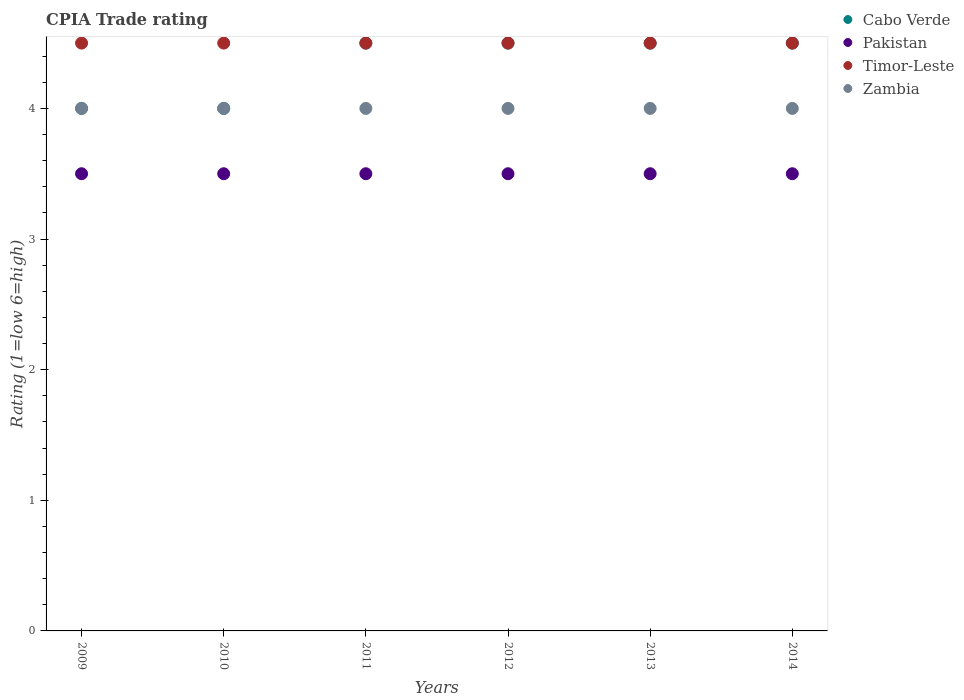Across all years, what is the minimum CPIA rating in Timor-Leste?
Your answer should be compact. 4.5. What is the difference between the CPIA rating in Pakistan in 2010 and that in 2012?
Ensure brevity in your answer.  0. What is the ratio of the CPIA rating in Pakistan in 2010 to that in 2014?
Give a very brief answer. 1. Is the difference between the CPIA rating in Cabo Verde in 2009 and 2013 greater than the difference between the CPIA rating in Pakistan in 2009 and 2013?
Your answer should be very brief. No. In how many years, is the CPIA rating in Timor-Leste greater than the average CPIA rating in Timor-Leste taken over all years?
Make the answer very short. 0. Is it the case that in every year, the sum of the CPIA rating in Cabo Verde and CPIA rating in Zambia  is greater than the sum of CPIA rating in Timor-Leste and CPIA rating in Pakistan?
Your answer should be very brief. Yes. Is the CPIA rating in Timor-Leste strictly less than the CPIA rating in Cabo Verde over the years?
Your answer should be very brief. No. Does the graph contain grids?
Keep it short and to the point. No. Where does the legend appear in the graph?
Make the answer very short. Top right. How many legend labels are there?
Your answer should be compact. 4. How are the legend labels stacked?
Your response must be concise. Vertical. What is the title of the graph?
Your response must be concise. CPIA Trade rating. Does "Russian Federation" appear as one of the legend labels in the graph?
Give a very brief answer. No. What is the label or title of the X-axis?
Keep it short and to the point. Years. What is the label or title of the Y-axis?
Provide a succinct answer. Rating (1=low 6=high). What is the Rating (1=low 6=high) in Timor-Leste in 2009?
Your response must be concise. 4.5. What is the Rating (1=low 6=high) in Zambia in 2009?
Provide a succinct answer. 4. What is the Rating (1=low 6=high) in Pakistan in 2010?
Provide a short and direct response. 3.5. What is the Rating (1=low 6=high) of Zambia in 2011?
Provide a succinct answer. 4. What is the Rating (1=low 6=high) of Cabo Verde in 2012?
Make the answer very short. 4.5. What is the Rating (1=low 6=high) in Pakistan in 2012?
Your answer should be compact. 3.5. What is the Rating (1=low 6=high) of Timor-Leste in 2012?
Offer a terse response. 4.5. What is the Rating (1=low 6=high) in Zambia in 2012?
Offer a very short reply. 4. What is the Rating (1=low 6=high) of Pakistan in 2013?
Keep it short and to the point. 3.5. What is the Rating (1=low 6=high) in Cabo Verde in 2014?
Your answer should be very brief. 4.5. Across all years, what is the maximum Rating (1=low 6=high) of Pakistan?
Make the answer very short. 3.5. Across all years, what is the maximum Rating (1=low 6=high) of Timor-Leste?
Keep it short and to the point. 4.5. Across all years, what is the maximum Rating (1=low 6=high) of Zambia?
Keep it short and to the point. 4. Across all years, what is the minimum Rating (1=low 6=high) of Pakistan?
Your answer should be very brief. 3.5. Across all years, what is the minimum Rating (1=low 6=high) of Timor-Leste?
Offer a very short reply. 4.5. What is the total Rating (1=low 6=high) of Pakistan in the graph?
Ensure brevity in your answer.  21. What is the total Rating (1=low 6=high) of Timor-Leste in the graph?
Provide a short and direct response. 27. What is the difference between the Rating (1=low 6=high) of Timor-Leste in 2009 and that in 2011?
Make the answer very short. 0. What is the difference between the Rating (1=low 6=high) in Cabo Verde in 2009 and that in 2012?
Provide a succinct answer. -0.5. What is the difference between the Rating (1=low 6=high) of Pakistan in 2009 and that in 2012?
Give a very brief answer. 0. What is the difference between the Rating (1=low 6=high) in Zambia in 2009 and that in 2012?
Provide a short and direct response. 0. What is the difference between the Rating (1=low 6=high) in Pakistan in 2009 and that in 2013?
Keep it short and to the point. 0. What is the difference between the Rating (1=low 6=high) in Timor-Leste in 2009 and that in 2013?
Make the answer very short. 0. What is the difference between the Rating (1=low 6=high) in Zambia in 2009 and that in 2013?
Ensure brevity in your answer.  0. What is the difference between the Rating (1=low 6=high) of Zambia in 2009 and that in 2014?
Your response must be concise. 0. What is the difference between the Rating (1=low 6=high) of Pakistan in 2010 and that in 2011?
Provide a short and direct response. 0. What is the difference between the Rating (1=low 6=high) in Pakistan in 2010 and that in 2012?
Provide a short and direct response. 0. What is the difference between the Rating (1=low 6=high) in Zambia in 2010 and that in 2012?
Provide a short and direct response. 0. What is the difference between the Rating (1=low 6=high) in Cabo Verde in 2010 and that in 2013?
Your answer should be very brief. -0.5. What is the difference between the Rating (1=low 6=high) in Pakistan in 2010 and that in 2013?
Your response must be concise. 0. What is the difference between the Rating (1=low 6=high) in Cabo Verde in 2010 and that in 2014?
Your response must be concise. -0.5. What is the difference between the Rating (1=low 6=high) in Pakistan in 2010 and that in 2014?
Your answer should be very brief. 0. What is the difference between the Rating (1=low 6=high) in Timor-Leste in 2010 and that in 2014?
Make the answer very short. 0. What is the difference between the Rating (1=low 6=high) in Cabo Verde in 2011 and that in 2012?
Provide a succinct answer. 0. What is the difference between the Rating (1=low 6=high) in Zambia in 2011 and that in 2012?
Offer a terse response. 0. What is the difference between the Rating (1=low 6=high) of Cabo Verde in 2011 and that in 2013?
Keep it short and to the point. 0. What is the difference between the Rating (1=low 6=high) in Cabo Verde in 2011 and that in 2014?
Offer a very short reply. 0. What is the difference between the Rating (1=low 6=high) in Pakistan in 2011 and that in 2014?
Keep it short and to the point. 0. What is the difference between the Rating (1=low 6=high) of Timor-Leste in 2011 and that in 2014?
Keep it short and to the point. 0. What is the difference between the Rating (1=low 6=high) of Zambia in 2011 and that in 2014?
Provide a short and direct response. 0. What is the difference between the Rating (1=low 6=high) in Cabo Verde in 2012 and that in 2013?
Your response must be concise. 0. What is the difference between the Rating (1=low 6=high) of Pakistan in 2012 and that in 2013?
Provide a succinct answer. 0. What is the difference between the Rating (1=low 6=high) in Timor-Leste in 2012 and that in 2013?
Keep it short and to the point. 0. What is the difference between the Rating (1=low 6=high) in Zambia in 2012 and that in 2013?
Your answer should be compact. 0. What is the difference between the Rating (1=low 6=high) in Cabo Verde in 2012 and that in 2014?
Provide a succinct answer. 0. What is the difference between the Rating (1=low 6=high) of Pakistan in 2012 and that in 2014?
Your answer should be compact. 0. What is the difference between the Rating (1=low 6=high) in Timor-Leste in 2012 and that in 2014?
Give a very brief answer. 0. What is the difference between the Rating (1=low 6=high) in Zambia in 2013 and that in 2014?
Provide a succinct answer. 0. What is the difference between the Rating (1=low 6=high) of Cabo Verde in 2009 and the Rating (1=low 6=high) of Pakistan in 2010?
Your answer should be very brief. 0.5. What is the difference between the Rating (1=low 6=high) of Cabo Verde in 2009 and the Rating (1=low 6=high) of Zambia in 2010?
Your answer should be very brief. 0. What is the difference between the Rating (1=low 6=high) in Pakistan in 2009 and the Rating (1=low 6=high) in Timor-Leste in 2010?
Offer a very short reply. -1. What is the difference between the Rating (1=low 6=high) of Pakistan in 2009 and the Rating (1=low 6=high) of Zambia in 2010?
Provide a succinct answer. -0.5. What is the difference between the Rating (1=low 6=high) of Timor-Leste in 2009 and the Rating (1=low 6=high) of Zambia in 2010?
Your response must be concise. 0.5. What is the difference between the Rating (1=low 6=high) in Cabo Verde in 2009 and the Rating (1=low 6=high) in Timor-Leste in 2011?
Give a very brief answer. -0.5. What is the difference between the Rating (1=low 6=high) in Cabo Verde in 2009 and the Rating (1=low 6=high) in Zambia in 2011?
Your answer should be compact. 0. What is the difference between the Rating (1=low 6=high) in Pakistan in 2009 and the Rating (1=low 6=high) in Zambia in 2011?
Ensure brevity in your answer.  -0.5. What is the difference between the Rating (1=low 6=high) in Timor-Leste in 2009 and the Rating (1=low 6=high) in Zambia in 2011?
Your response must be concise. 0.5. What is the difference between the Rating (1=low 6=high) in Cabo Verde in 2009 and the Rating (1=low 6=high) in Pakistan in 2012?
Your answer should be very brief. 0.5. What is the difference between the Rating (1=low 6=high) in Cabo Verde in 2009 and the Rating (1=low 6=high) in Timor-Leste in 2012?
Ensure brevity in your answer.  -0.5. What is the difference between the Rating (1=low 6=high) in Cabo Verde in 2009 and the Rating (1=low 6=high) in Zambia in 2012?
Give a very brief answer. 0. What is the difference between the Rating (1=low 6=high) in Timor-Leste in 2009 and the Rating (1=low 6=high) in Zambia in 2012?
Keep it short and to the point. 0.5. What is the difference between the Rating (1=low 6=high) of Cabo Verde in 2009 and the Rating (1=low 6=high) of Timor-Leste in 2013?
Your answer should be compact. -0.5. What is the difference between the Rating (1=low 6=high) of Pakistan in 2009 and the Rating (1=low 6=high) of Zambia in 2013?
Ensure brevity in your answer.  -0.5. What is the difference between the Rating (1=low 6=high) of Timor-Leste in 2009 and the Rating (1=low 6=high) of Zambia in 2013?
Offer a very short reply. 0.5. What is the difference between the Rating (1=low 6=high) in Pakistan in 2009 and the Rating (1=low 6=high) in Timor-Leste in 2014?
Provide a short and direct response. -1. What is the difference between the Rating (1=low 6=high) in Cabo Verde in 2010 and the Rating (1=low 6=high) in Pakistan in 2011?
Your response must be concise. 0.5. What is the difference between the Rating (1=low 6=high) in Cabo Verde in 2010 and the Rating (1=low 6=high) in Timor-Leste in 2011?
Make the answer very short. -0.5. What is the difference between the Rating (1=low 6=high) of Cabo Verde in 2010 and the Rating (1=low 6=high) of Zambia in 2011?
Keep it short and to the point. 0. What is the difference between the Rating (1=low 6=high) of Pakistan in 2010 and the Rating (1=low 6=high) of Zambia in 2011?
Provide a short and direct response. -0.5. What is the difference between the Rating (1=low 6=high) in Cabo Verde in 2010 and the Rating (1=low 6=high) in Zambia in 2012?
Your response must be concise. 0. What is the difference between the Rating (1=low 6=high) in Pakistan in 2010 and the Rating (1=low 6=high) in Timor-Leste in 2012?
Your answer should be compact. -1. What is the difference between the Rating (1=low 6=high) of Pakistan in 2010 and the Rating (1=low 6=high) of Zambia in 2012?
Your answer should be very brief. -0.5. What is the difference between the Rating (1=low 6=high) in Cabo Verde in 2010 and the Rating (1=low 6=high) in Pakistan in 2013?
Your answer should be compact. 0.5. What is the difference between the Rating (1=low 6=high) of Cabo Verde in 2010 and the Rating (1=low 6=high) of Timor-Leste in 2013?
Ensure brevity in your answer.  -0.5. What is the difference between the Rating (1=low 6=high) of Pakistan in 2010 and the Rating (1=low 6=high) of Timor-Leste in 2013?
Give a very brief answer. -1. What is the difference between the Rating (1=low 6=high) in Timor-Leste in 2010 and the Rating (1=low 6=high) in Zambia in 2013?
Offer a terse response. 0.5. What is the difference between the Rating (1=low 6=high) in Cabo Verde in 2010 and the Rating (1=low 6=high) in Zambia in 2014?
Offer a terse response. 0. What is the difference between the Rating (1=low 6=high) in Cabo Verde in 2011 and the Rating (1=low 6=high) in Pakistan in 2012?
Provide a succinct answer. 1. What is the difference between the Rating (1=low 6=high) in Pakistan in 2011 and the Rating (1=low 6=high) in Timor-Leste in 2013?
Provide a short and direct response. -1. What is the difference between the Rating (1=low 6=high) in Pakistan in 2011 and the Rating (1=low 6=high) in Zambia in 2013?
Provide a short and direct response. -0.5. What is the difference between the Rating (1=low 6=high) in Timor-Leste in 2011 and the Rating (1=low 6=high) in Zambia in 2013?
Your answer should be very brief. 0.5. What is the difference between the Rating (1=low 6=high) in Cabo Verde in 2011 and the Rating (1=low 6=high) in Pakistan in 2014?
Ensure brevity in your answer.  1. What is the difference between the Rating (1=low 6=high) of Cabo Verde in 2011 and the Rating (1=low 6=high) of Timor-Leste in 2014?
Offer a terse response. 0. What is the difference between the Rating (1=low 6=high) of Cabo Verde in 2011 and the Rating (1=low 6=high) of Zambia in 2014?
Your answer should be compact. 0.5. What is the difference between the Rating (1=low 6=high) of Pakistan in 2011 and the Rating (1=low 6=high) of Timor-Leste in 2014?
Provide a succinct answer. -1. What is the difference between the Rating (1=low 6=high) in Pakistan in 2011 and the Rating (1=low 6=high) in Zambia in 2014?
Offer a terse response. -0.5. What is the difference between the Rating (1=low 6=high) in Cabo Verde in 2012 and the Rating (1=low 6=high) in Pakistan in 2013?
Offer a very short reply. 1. What is the difference between the Rating (1=low 6=high) of Cabo Verde in 2012 and the Rating (1=low 6=high) of Timor-Leste in 2013?
Keep it short and to the point. 0. What is the difference between the Rating (1=low 6=high) in Cabo Verde in 2012 and the Rating (1=low 6=high) in Zambia in 2013?
Ensure brevity in your answer.  0.5. What is the difference between the Rating (1=low 6=high) in Pakistan in 2012 and the Rating (1=low 6=high) in Timor-Leste in 2013?
Keep it short and to the point. -1. What is the difference between the Rating (1=low 6=high) of Cabo Verde in 2012 and the Rating (1=low 6=high) of Pakistan in 2014?
Provide a short and direct response. 1. What is the difference between the Rating (1=low 6=high) in Cabo Verde in 2012 and the Rating (1=low 6=high) in Timor-Leste in 2014?
Offer a very short reply. 0. What is the difference between the Rating (1=low 6=high) of Pakistan in 2012 and the Rating (1=low 6=high) of Zambia in 2014?
Your answer should be very brief. -0.5. What is the difference between the Rating (1=low 6=high) of Timor-Leste in 2012 and the Rating (1=low 6=high) of Zambia in 2014?
Give a very brief answer. 0.5. What is the difference between the Rating (1=low 6=high) in Pakistan in 2013 and the Rating (1=low 6=high) in Timor-Leste in 2014?
Ensure brevity in your answer.  -1. What is the difference between the Rating (1=low 6=high) of Timor-Leste in 2013 and the Rating (1=low 6=high) of Zambia in 2014?
Your response must be concise. 0.5. What is the average Rating (1=low 6=high) in Cabo Verde per year?
Offer a terse response. 4.33. What is the average Rating (1=low 6=high) of Pakistan per year?
Provide a short and direct response. 3.5. What is the average Rating (1=low 6=high) in Zambia per year?
Give a very brief answer. 4. In the year 2009, what is the difference between the Rating (1=low 6=high) in Cabo Verde and Rating (1=low 6=high) in Pakistan?
Offer a very short reply. 0.5. In the year 2009, what is the difference between the Rating (1=low 6=high) of Cabo Verde and Rating (1=low 6=high) of Zambia?
Ensure brevity in your answer.  0. In the year 2009, what is the difference between the Rating (1=low 6=high) in Pakistan and Rating (1=low 6=high) in Zambia?
Provide a short and direct response. -0.5. In the year 2010, what is the difference between the Rating (1=low 6=high) in Cabo Verde and Rating (1=low 6=high) in Timor-Leste?
Keep it short and to the point. -0.5. In the year 2010, what is the difference between the Rating (1=low 6=high) of Timor-Leste and Rating (1=low 6=high) of Zambia?
Give a very brief answer. 0.5. In the year 2011, what is the difference between the Rating (1=low 6=high) of Cabo Verde and Rating (1=low 6=high) of Pakistan?
Provide a succinct answer. 1. In the year 2011, what is the difference between the Rating (1=low 6=high) of Cabo Verde and Rating (1=low 6=high) of Zambia?
Your response must be concise. 0.5. In the year 2011, what is the difference between the Rating (1=low 6=high) in Pakistan and Rating (1=low 6=high) in Timor-Leste?
Provide a succinct answer. -1. In the year 2011, what is the difference between the Rating (1=low 6=high) of Pakistan and Rating (1=low 6=high) of Zambia?
Provide a succinct answer. -0.5. In the year 2013, what is the difference between the Rating (1=low 6=high) of Cabo Verde and Rating (1=low 6=high) of Pakistan?
Provide a succinct answer. 1. In the year 2013, what is the difference between the Rating (1=low 6=high) of Timor-Leste and Rating (1=low 6=high) of Zambia?
Make the answer very short. 0.5. In the year 2014, what is the difference between the Rating (1=low 6=high) of Cabo Verde and Rating (1=low 6=high) of Zambia?
Your answer should be compact. 0.5. In the year 2014, what is the difference between the Rating (1=low 6=high) of Pakistan and Rating (1=low 6=high) of Timor-Leste?
Provide a succinct answer. -1. What is the ratio of the Rating (1=low 6=high) in Pakistan in 2009 to that in 2010?
Keep it short and to the point. 1. What is the ratio of the Rating (1=low 6=high) in Cabo Verde in 2009 to that in 2011?
Give a very brief answer. 0.89. What is the ratio of the Rating (1=low 6=high) in Zambia in 2009 to that in 2011?
Provide a short and direct response. 1. What is the ratio of the Rating (1=low 6=high) of Pakistan in 2009 to that in 2012?
Offer a terse response. 1. What is the ratio of the Rating (1=low 6=high) of Timor-Leste in 2009 to that in 2012?
Make the answer very short. 1. What is the ratio of the Rating (1=low 6=high) in Zambia in 2009 to that in 2012?
Offer a very short reply. 1. What is the ratio of the Rating (1=low 6=high) in Pakistan in 2009 to that in 2013?
Your response must be concise. 1. What is the ratio of the Rating (1=low 6=high) of Timor-Leste in 2009 to that in 2013?
Provide a short and direct response. 1. What is the ratio of the Rating (1=low 6=high) of Zambia in 2009 to that in 2013?
Offer a very short reply. 1. What is the ratio of the Rating (1=low 6=high) of Cabo Verde in 2009 to that in 2014?
Give a very brief answer. 0.89. What is the ratio of the Rating (1=low 6=high) of Pakistan in 2009 to that in 2014?
Keep it short and to the point. 1. What is the ratio of the Rating (1=low 6=high) in Zambia in 2009 to that in 2014?
Offer a very short reply. 1. What is the ratio of the Rating (1=low 6=high) in Cabo Verde in 2010 to that in 2011?
Offer a very short reply. 0.89. What is the ratio of the Rating (1=low 6=high) of Pakistan in 2010 to that in 2011?
Give a very brief answer. 1. What is the ratio of the Rating (1=low 6=high) of Zambia in 2010 to that in 2011?
Make the answer very short. 1. What is the ratio of the Rating (1=low 6=high) in Cabo Verde in 2010 to that in 2012?
Your answer should be very brief. 0.89. What is the ratio of the Rating (1=low 6=high) of Pakistan in 2010 to that in 2012?
Offer a terse response. 1. What is the ratio of the Rating (1=low 6=high) in Cabo Verde in 2010 to that in 2013?
Ensure brevity in your answer.  0.89. What is the ratio of the Rating (1=low 6=high) of Pakistan in 2010 to that in 2013?
Make the answer very short. 1. What is the ratio of the Rating (1=low 6=high) of Timor-Leste in 2010 to that in 2014?
Your answer should be very brief. 1. What is the ratio of the Rating (1=low 6=high) of Zambia in 2010 to that in 2014?
Your response must be concise. 1. What is the ratio of the Rating (1=low 6=high) in Cabo Verde in 2011 to that in 2012?
Offer a terse response. 1. What is the ratio of the Rating (1=low 6=high) of Pakistan in 2011 to that in 2012?
Your response must be concise. 1. What is the ratio of the Rating (1=low 6=high) in Timor-Leste in 2011 to that in 2012?
Provide a short and direct response. 1. What is the ratio of the Rating (1=low 6=high) in Zambia in 2011 to that in 2012?
Ensure brevity in your answer.  1. What is the ratio of the Rating (1=low 6=high) in Cabo Verde in 2011 to that in 2013?
Make the answer very short. 1. What is the ratio of the Rating (1=low 6=high) of Pakistan in 2011 to that in 2013?
Offer a very short reply. 1. What is the ratio of the Rating (1=low 6=high) in Timor-Leste in 2011 to that in 2013?
Your answer should be compact. 1. What is the ratio of the Rating (1=low 6=high) of Cabo Verde in 2011 to that in 2014?
Your answer should be very brief. 1. What is the ratio of the Rating (1=low 6=high) of Timor-Leste in 2011 to that in 2014?
Your answer should be very brief. 1. What is the ratio of the Rating (1=low 6=high) in Pakistan in 2012 to that in 2013?
Your answer should be compact. 1. What is the ratio of the Rating (1=low 6=high) in Timor-Leste in 2012 to that in 2013?
Your answer should be compact. 1. What is the ratio of the Rating (1=low 6=high) of Cabo Verde in 2012 to that in 2014?
Offer a very short reply. 1. What is the ratio of the Rating (1=low 6=high) of Pakistan in 2012 to that in 2014?
Provide a short and direct response. 1. What is the ratio of the Rating (1=low 6=high) of Timor-Leste in 2012 to that in 2014?
Keep it short and to the point. 1. What is the ratio of the Rating (1=low 6=high) of Cabo Verde in 2013 to that in 2014?
Keep it short and to the point. 1. What is the ratio of the Rating (1=low 6=high) of Pakistan in 2013 to that in 2014?
Offer a very short reply. 1. What is the ratio of the Rating (1=low 6=high) in Timor-Leste in 2013 to that in 2014?
Provide a short and direct response. 1. What is the ratio of the Rating (1=low 6=high) of Zambia in 2013 to that in 2014?
Your answer should be very brief. 1. What is the difference between the highest and the second highest Rating (1=low 6=high) of Pakistan?
Your response must be concise. 0. What is the difference between the highest and the second highest Rating (1=low 6=high) of Zambia?
Offer a terse response. 0. What is the difference between the highest and the lowest Rating (1=low 6=high) in Timor-Leste?
Offer a very short reply. 0. 